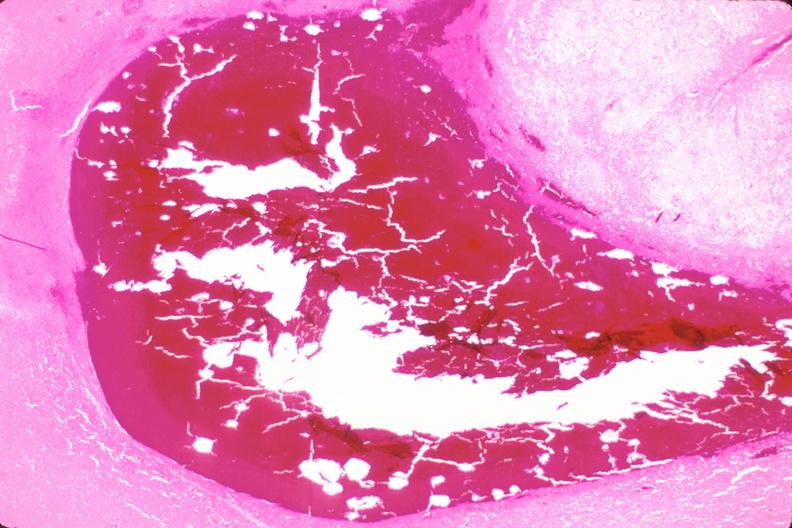where is this?
Answer the question using a single word or phrase. Nervous 